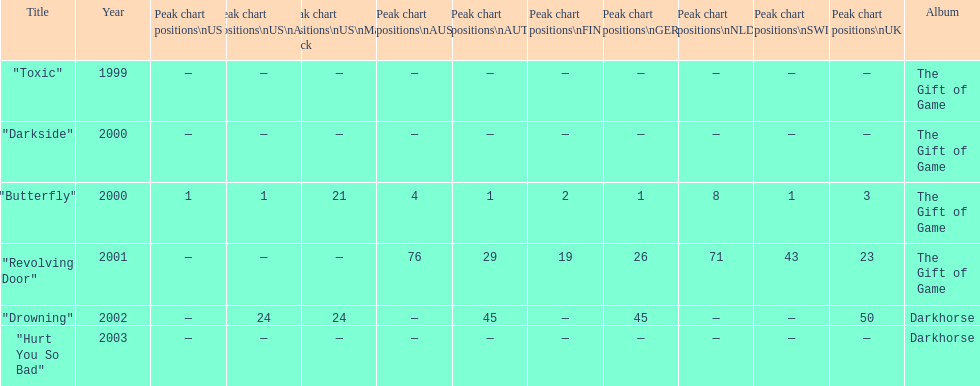Which single ranks 1 in us and 1 in us alt? "Butterfly". 